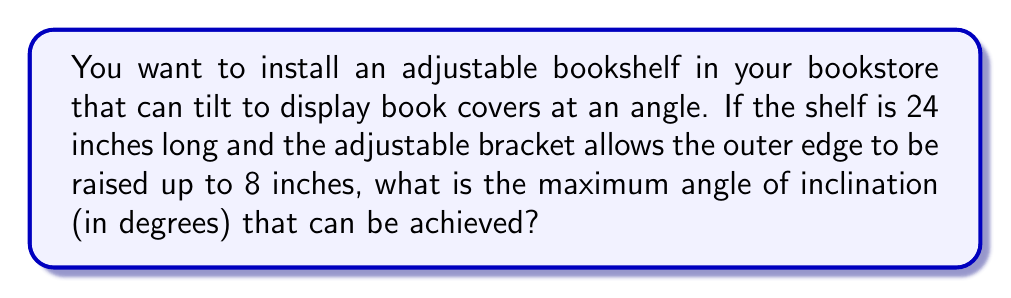What is the answer to this math problem? To solve this problem, we need to use trigonometry. Let's break it down step-by-step:

1. Visualize the problem:
   [asy]
   import geometry;
   
   pair A = (0,0), B = (24,0), C = (24,8);
   draw(A--B--C--A);
   
   label("24\"", (12,0), S);
   label("8\"", (24,4), E);
   label("$\theta$", (2,1), NW);
   
   draw(A--(0,1)--(-1,1), arrow=Arrow(TeXHead));
   [/asy]

2. We have a right triangle where:
   - The base (adjacent side) is 24 inches
   - The height (opposite side) is 8 inches
   - We need to find the angle $\theta$

3. In this case, we can use the arctangent function to find the angle:

   $$\theta = \arctan(\frac{\text{opposite}}{\text{adjacent}})$$

4. Substituting our values:

   $$\theta = \arctan(\frac{8}{24})$$

5. Simplify the fraction:

   $$\theta = \arctan(\frac{1}{3})$$

6. Calculate the arctangent:

   $$\theta \approx 18.43^\circ$$

Therefore, the maximum angle of inclination that can be achieved is approximately 18.43 degrees.
Answer: $18.43^\circ$ (rounded to two decimal places) 